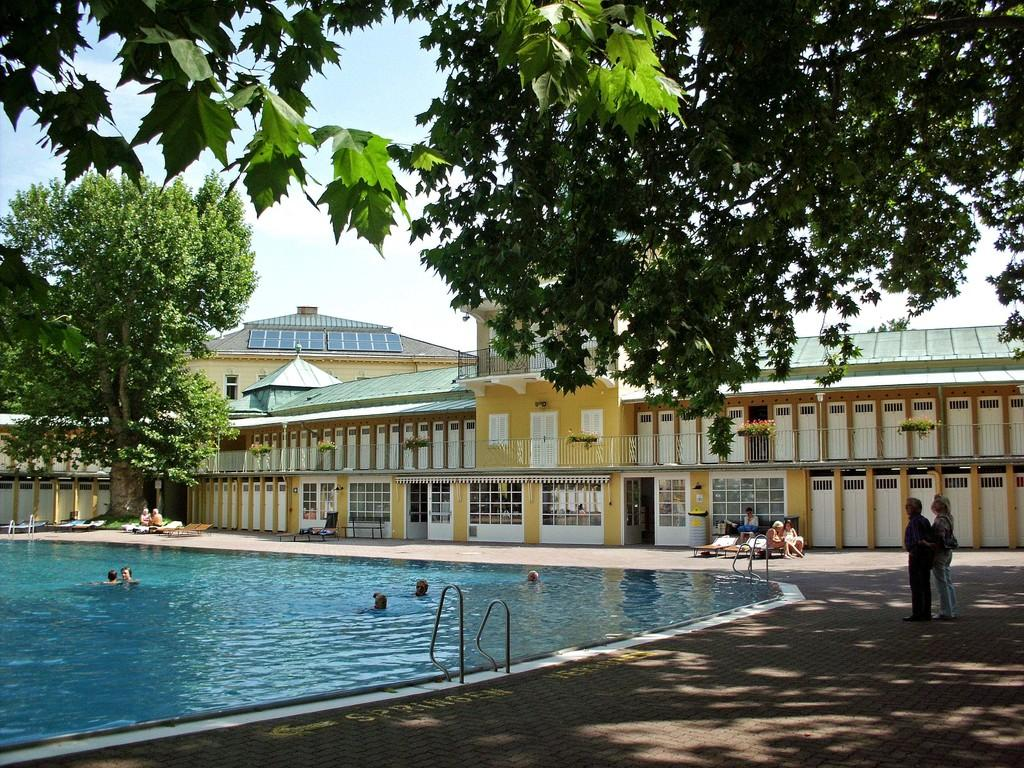What is the main feature of the image? There is a swimming pool in the image. Can you describe the people in the image? There are people in the image. What other structures are visible in the image? There are buildings in the image. What type of natural elements can be seen in the image? There are trees in the image. What is visible in the background of the image? The sky is visible in the image. What type of behavior does the governor exhibit in the image? There is no governor present in the image, so it is not possible to determine their behavior. What color is the rose in the image? There is no rose present in the image. 